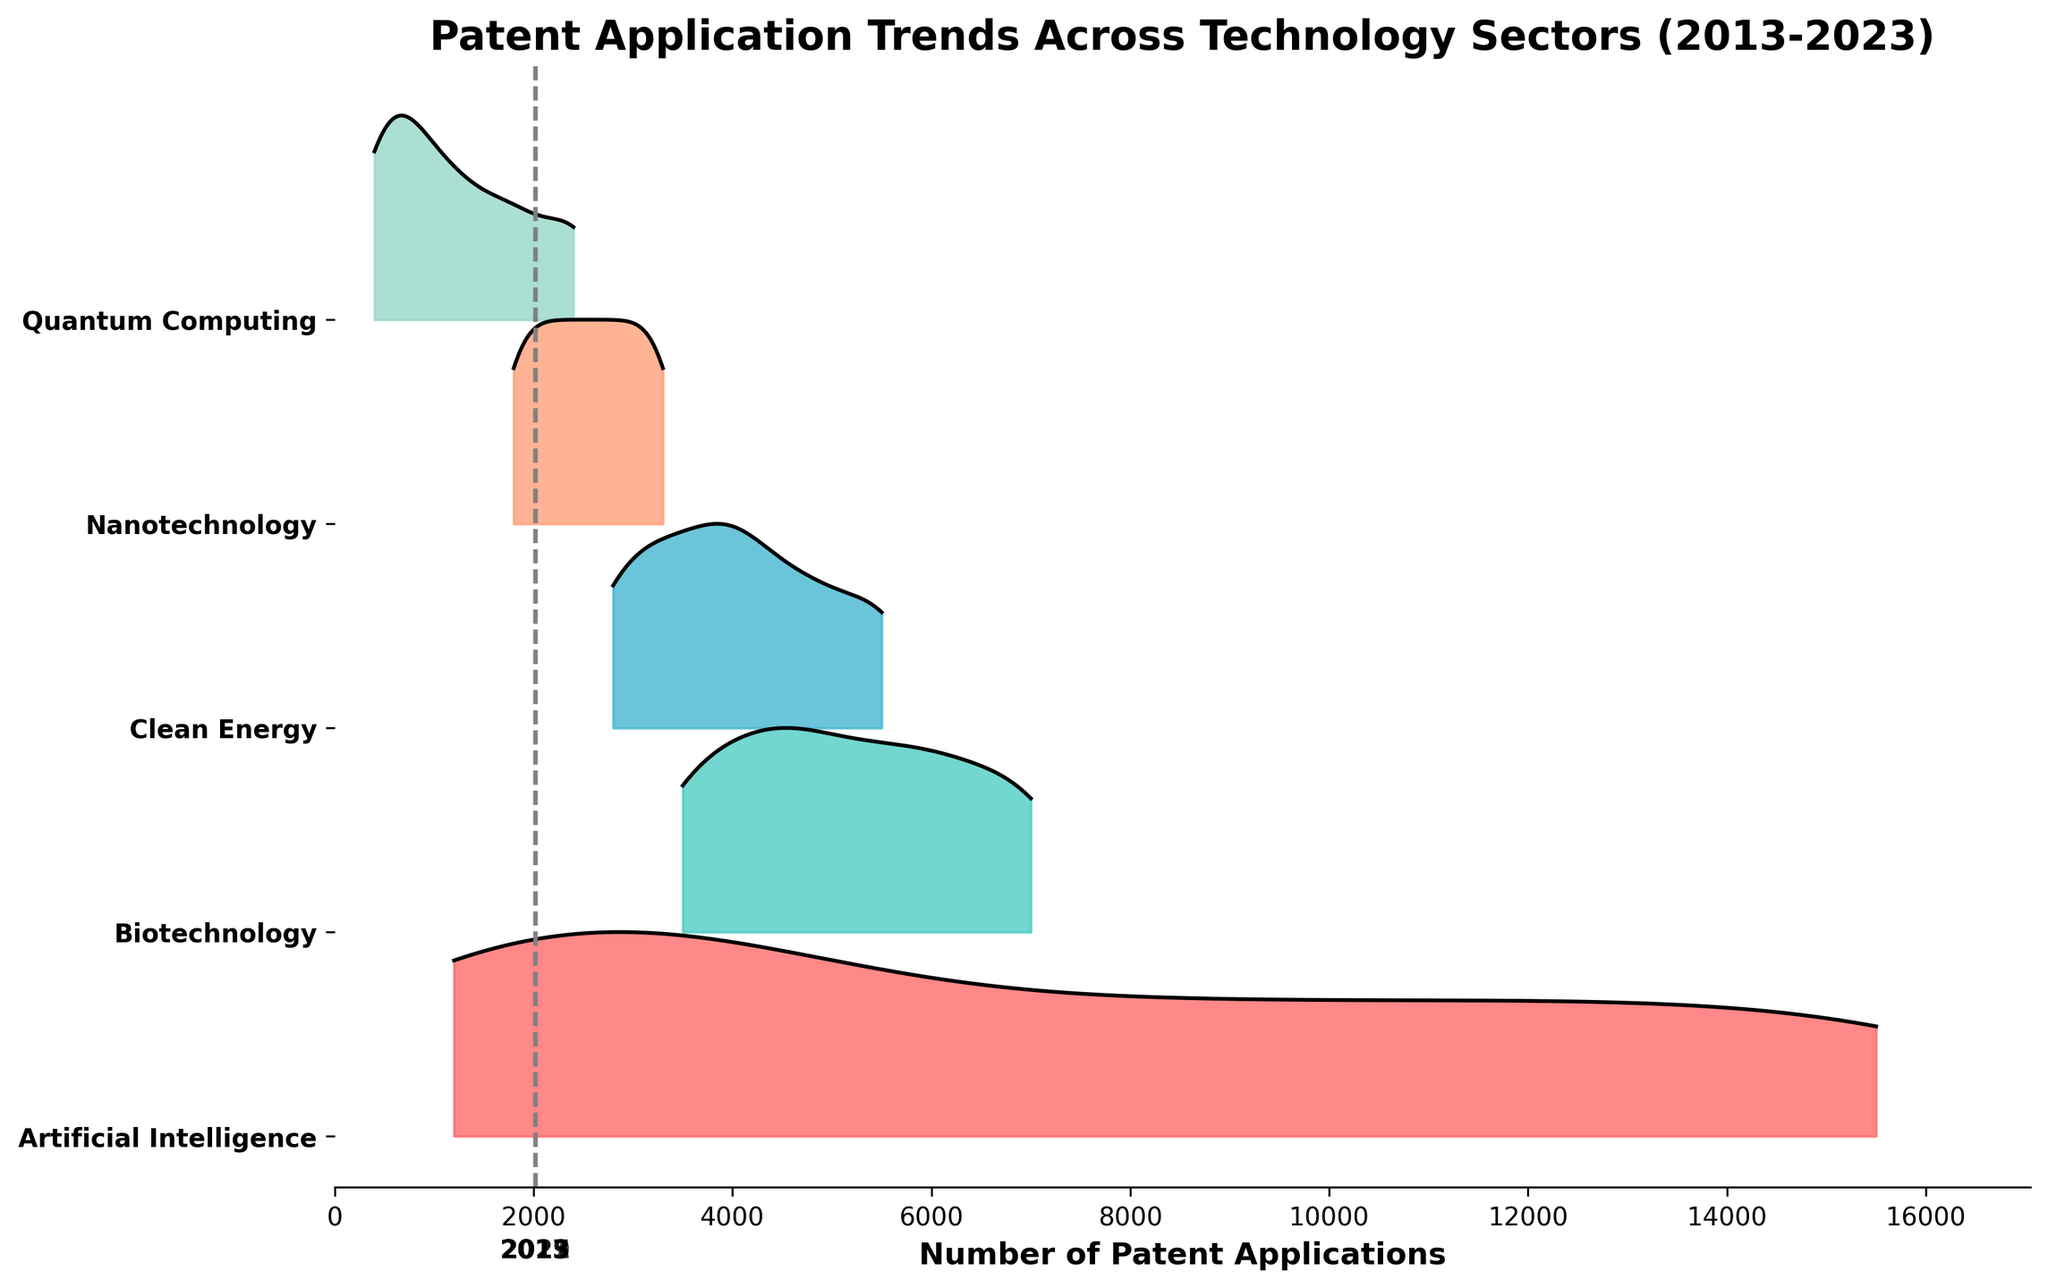Which technology sector has the highest number of patent applications in 2023? First, identify the 2023 data on the x-axis (furthest to the right). Compare the height of the ridges for each sector. The tallest ridge corresponds to Artificial Intelligence.
Answer: Artificial Intelligence What is the trend in patent applications for the Nanotechnology sector from 2013 to 2023? Examine the ridgeline from left (2013) to right (2023) for Nanotechnology. Observe if the ridge becomes higher or lower over the years. The height increases gradually, indicating growth over time.
Answer: Increasing Which sector had the lowest number of patent applications in 2013? On the far left of the plot, compare the heights of the ridges for 2013 across all sectors. Quantum Computing has the lowest ridge.
Answer: Quantum Computing How do the number of patent applications in Biotechnology in 2015 compare with those in Clean Energy in the same year? Identify the ridges for Biotechnology and Clean Energy in the year 2015. Compare their heights. Biotechnology's ridge is higher than Clean Energy's.
Answer: Biotechnology is higher What is the approximate number of applications for Clean Energy in 2019? Locate the ridge for Clean Energy in 2019 and identify the height of the ridge on the x-axis. It corresponds to approximately 4200 applications.
Answer: 4200 From which year does Artificial Intelligence see a dramatic rise in patent applications? Track the height of the ridgeline for Artificial Intelligence across the years. A noticeable sharp increase occurs after 2017.
Answer: After 2017 Which sector shows the most consistent growth trend in patent applications over the decade? Observe the relative height changes of the ridges from 2013 to 2023 across all sectors. Artificial Intelligence shows consistent and steep growth.
Answer: Artificial Intelligence In 2021, which sector has the second-highest number of patent applications? Examine the heights of the ridges for the year 2021. The second tallest ridge after Artificial Intelligence's is Biotechnology.
Answer: Biotechnology 